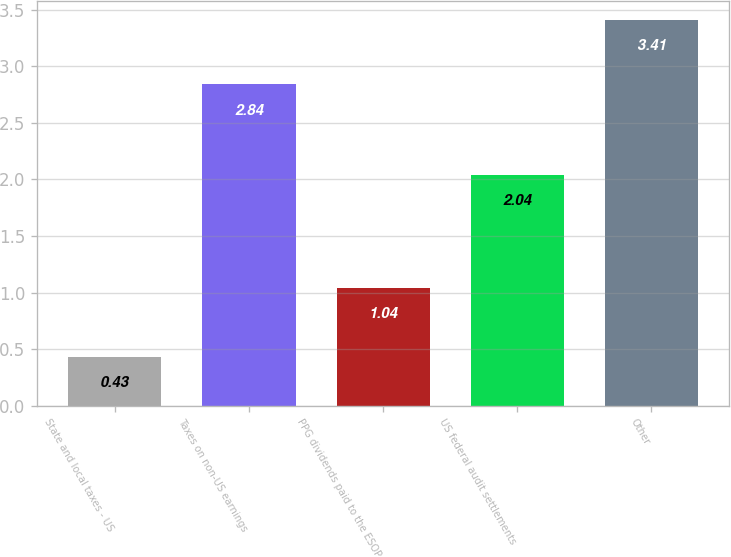Convert chart to OTSL. <chart><loc_0><loc_0><loc_500><loc_500><bar_chart><fcel>State and local taxes - US<fcel>Taxes on non-US earnings<fcel>PPG dividends paid to the ESOP<fcel>US federal audit settlements<fcel>Other<nl><fcel>0.43<fcel>2.84<fcel>1.04<fcel>2.04<fcel>3.41<nl></chart> 